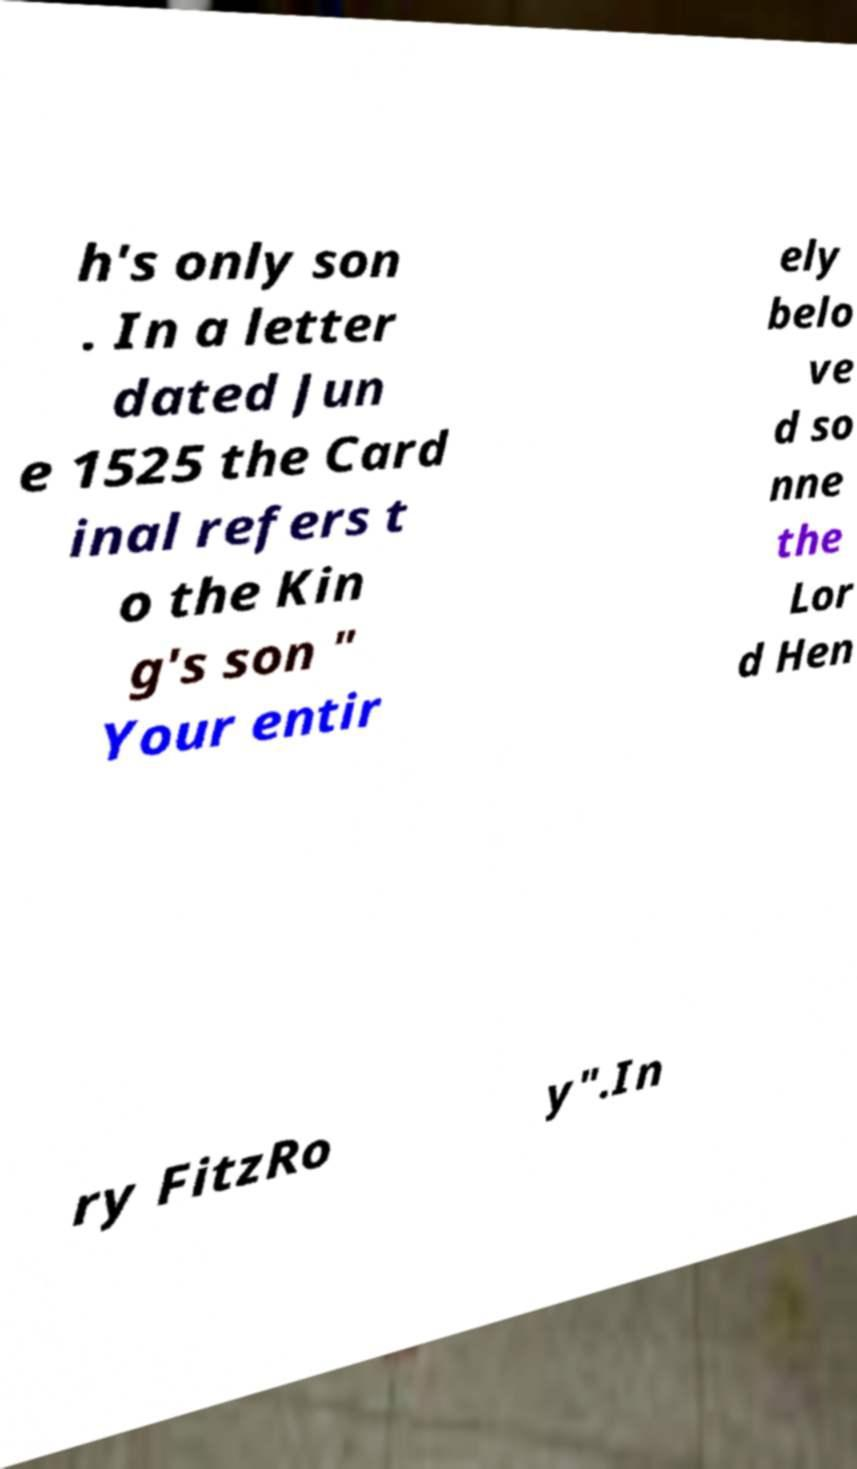Please identify and transcribe the text found in this image. h's only son . In a letter dated Jun e 1525 the Card inal refers t o the Kin g's son " Your entir ely belo ve d so nne the Lor d Hen ry FitzRo y".In 